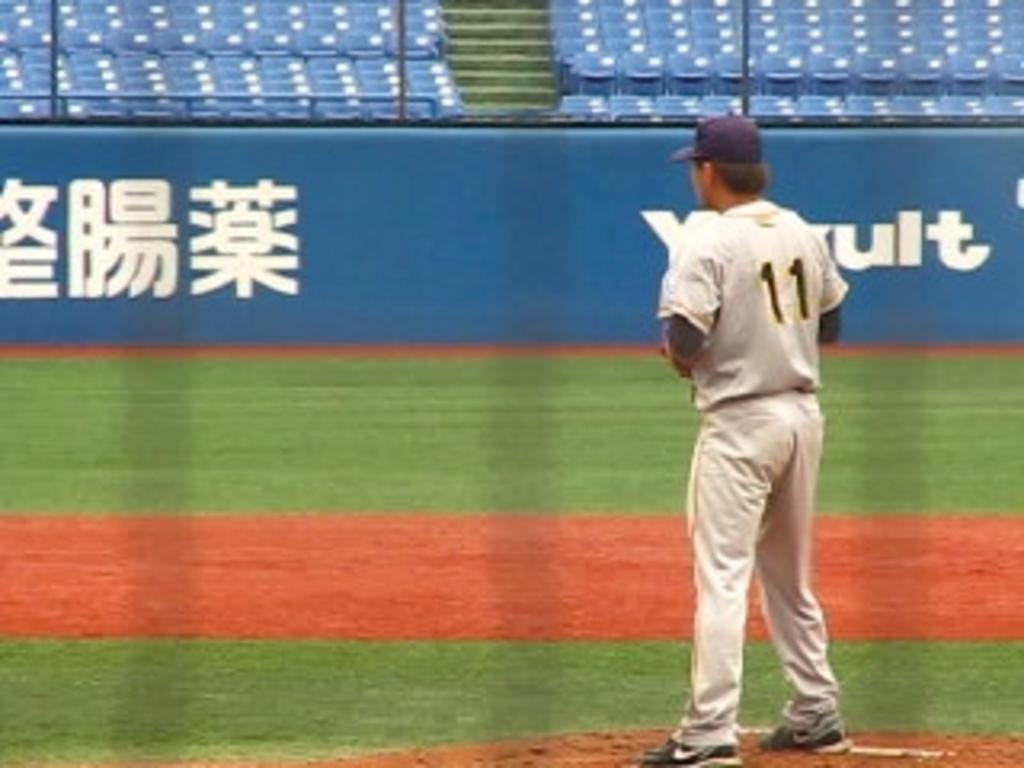<image>
Write a terse but informative summary of the picture. Player number 11 is standing on the mount preparing to pitch the ball. 